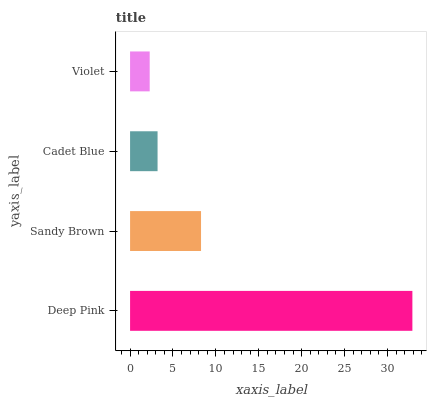Is Violet the minimum?
Answer yes or no. Yes. Is Deep Pink the maximum?
Answer yes or no. Yes. Is Sandy Brown the minimum?
Answer yes or no. No. Is Sandy Brown the maximum?
Answer yes or no. No. Is Deep Pink greater than Sandy Brown?
Answer yes or no. Yes. Is Sandy Brown less than Deep Pink?
Answer yes or no. Yes. Is Sandy Brown greater than Deep Pink?
Answer yes or no. No. Is Deep Pink less than Sandy Brown?
Answer yes or no. No. Is Sandy Brown the high median?
Answer yes or no. Yes. Is Cadet Blue the low median?
Answer yes or no. Yes. Is Deep Pink the high median?
Answer yes or no. No. Is Sandy Brown the low median?
Answer yes or no. No. 